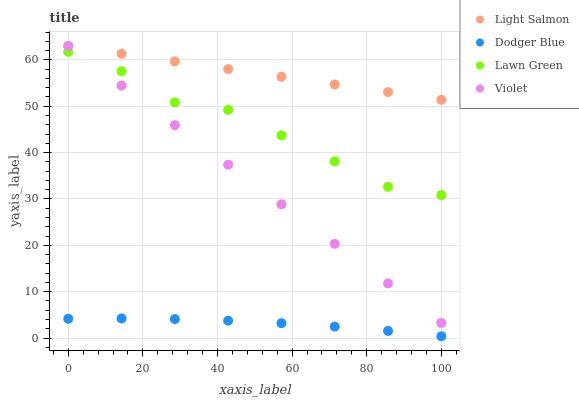Does Dodger Blue have the minimum area under the curve?
Answer yes or no. Yes. Does Light Salmon have the maximum area under the curve?
Answer yes or no. Yes. Does Light Salmon have the minimum area under the curve?
Answer yes or no. No. Does Dodger Blue have the maximum area under the curve?
Answer yes or no. No. Is Violet the smoothest?
Answer yes or no. Yes. Is Lawn Green the roughest?
Answer yes or no. Yes. Is Light Salmon the smoothest?
Answer yes or no. No. Is Light Salmon the roughest?
Answer yes or no. No. Does Dodger Blue have the lowest value?
Answer yes or no. Yes. Does Light Salmon have the lowest value?
Answer yes or no. No. Does Violet have the highest value?
Answer yes or no. Yes. Does Dodger Blue have the highest value?
Answer yes or no. No. Is Dodger Blue less than Lawn Green?
Answer yes or no. Yes. Is Lawn Green greater than Dodger Blue?
Answer yes or no. Yes. Does Light Salmon intersect Violet?
Answer yes or no. Yes. Is Light Salmon less than Violet?
Answer yes or no. No. Is Light Salmon greater than Violet?
Answer yes or no. No. Does Dodger Blue intersect Lawn Green?
Answer yes or no. No. 